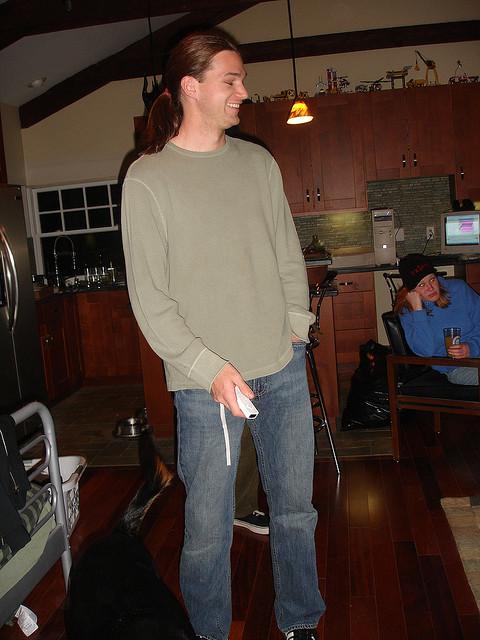Is this a cook?
Keep it brief. No. What character is the man dressed as?
Answer briefly. None. What color is the sweater?
Be succinct. Gray. What is the boy wearing?
Be succinct. Sweater. What is the man holding?
Be succinct. Wii remote. Is there a dog bowl in this picture?
Answer briefly. Yes. 